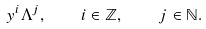Convert formula to latex. <formula><loc_0><loc_0><loc_500><loc_500>y ^ { i } \Lambda ^ { j } , \quad i \in \mathbb { Z } , \quad j \in \mathbb { N } .</formula> 